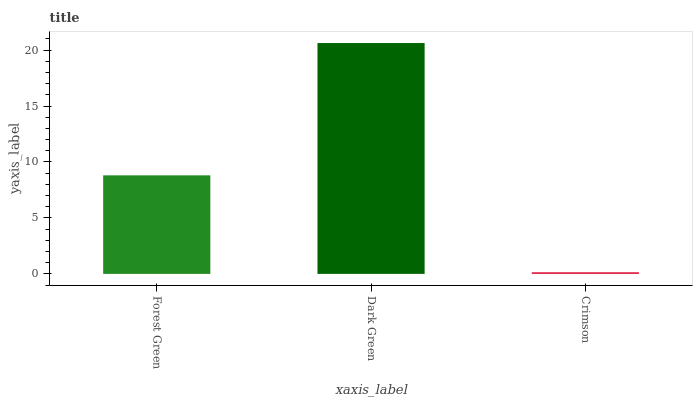Is Crimson the minimum?
Answer yes or no. Yes. Is Dark Green the maximum?
Answer yes or no. Yes. Is Dark Green the minimum?
Answer yes or no. No. Is Crimson the maximum?
Answer yes or no. No. Is Dark Green greater than Crimson?
Answer yes or no. Yes. Is Crimson less than Dark Green?
Answer yes or no. Yes. Is Crimson greater than Dark Green?
Answer yes or no. No. Is Dark Green less than Crimson?
Answer yes or no. No. Is Forest Green the high median?
Answer yes or no. Yes. Is Forest Green the low median?
Answer yes or no. Yes. Is Dark Green the high median?
Answer yes or no. No. Is Crimson the low median?
Answer yes or no. No. 